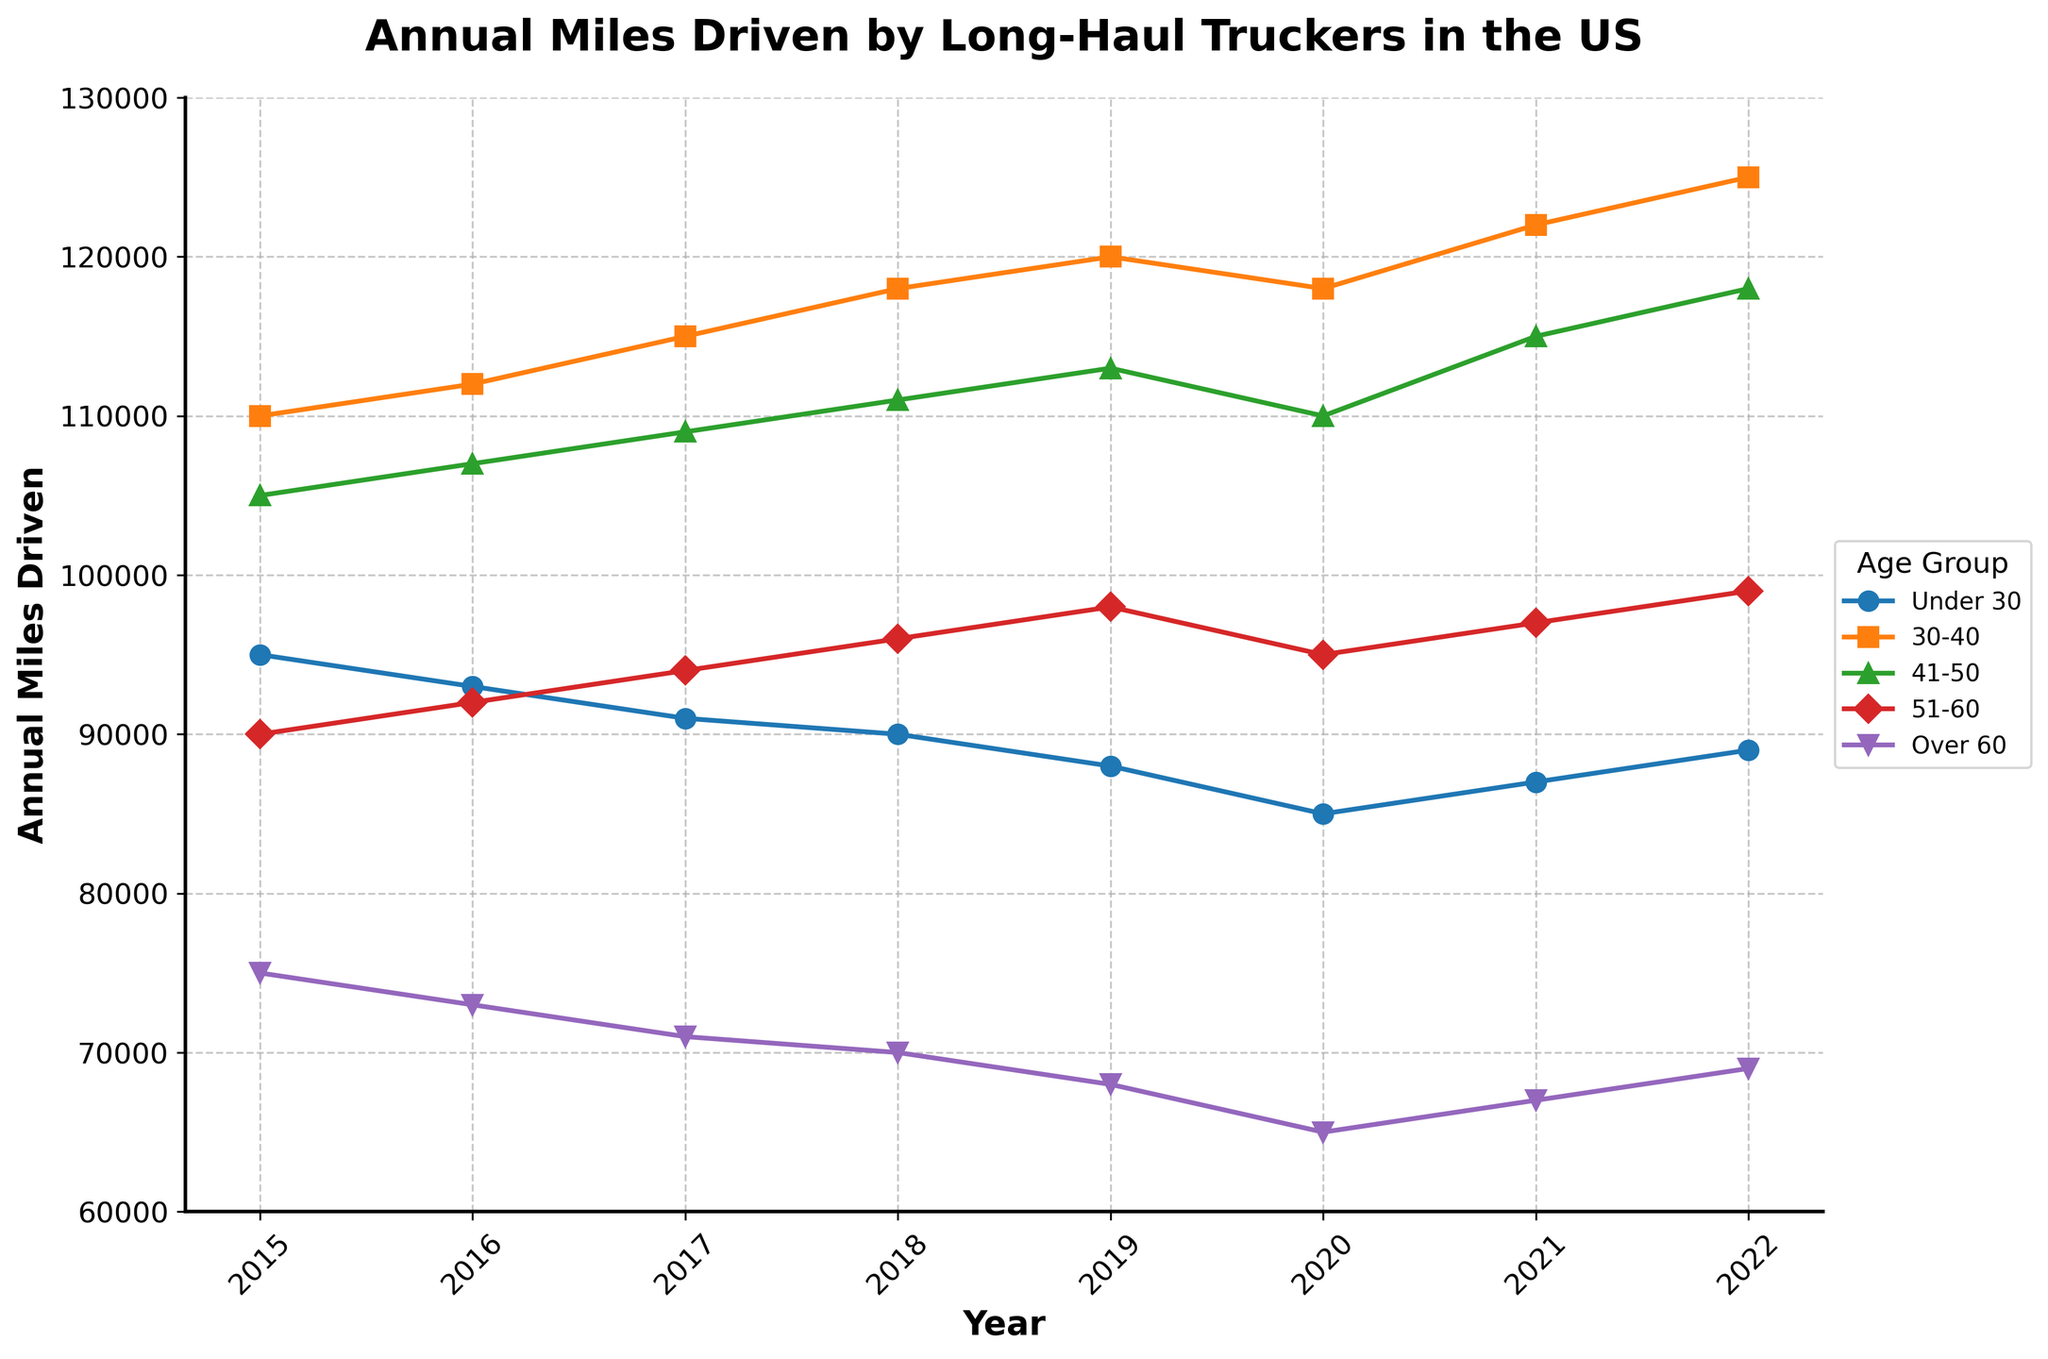What was the annual mileage driven by truckers under 30 in 2020? Look at the data point for the age group "Under 30" in the year 2020 on the plot.
Answer: 85,000 Which age group drove the highest number of miles in 2019? Identify which line reaches the highest value on the y-axis for the year 2019.
Answer: 30-40 How did the annual miles driven by the 51-60 age group change from 2015 to 2022? Subtract the value for the 51-60 age group in 2015 from the value in 2022.
Answer: 9,000 Are the miles driven by the 30-40 age group increasing or decreasing over time? Check whether the line for the 30-40 age group is generally sloping upward or downward from 2015 to 2022.
Answer: Increasing Which age group had the most significant drop in annual miles driven between any two consecutive years? Compare the differences in annual mileage for all age groups between consecutive years and identify the largest drop.
Answer: Over 60 (2019 to 2020) What's the average annual mileage driven by the 41-50 age group from 2015 to 2022? Sum the annual mileage for the 41-50 age group from 2015 to 2022 and divide by the number of years. (105,000 + 107,000 + 109,000 + 111,000 + 113,000 + 110,000 + 115,000 + 118,000) / 8 = 111,000
Answer: 111,000 Which age groups show a marked increase in annual miles driven in 2022 compared to 2020? Compare the values for all age groups between 2020 and 2022 and highlight those that show an increase.
Answer: 30-40, 41-50, 51-60, Under 30, Over 60 By how much did the annual mileage driven by the "Over 60" group change from 2015 to 2022? Subtract the value for the Over 60 group in 2022 from that in 2015.
Answer: -6,000 In which year did the 30-40 age group see the largest year-over-year increase in mileage? Calculate the difference in mileage for the 30-40 age group between consecutive years and identify the largest increase.
Answer: 2022 Which age group had the least variability in annual miles driven over the years? Evaluate the range (difference between the maximum and minimum values) for each age group and identify the smallest range.
Answer: Under 30 